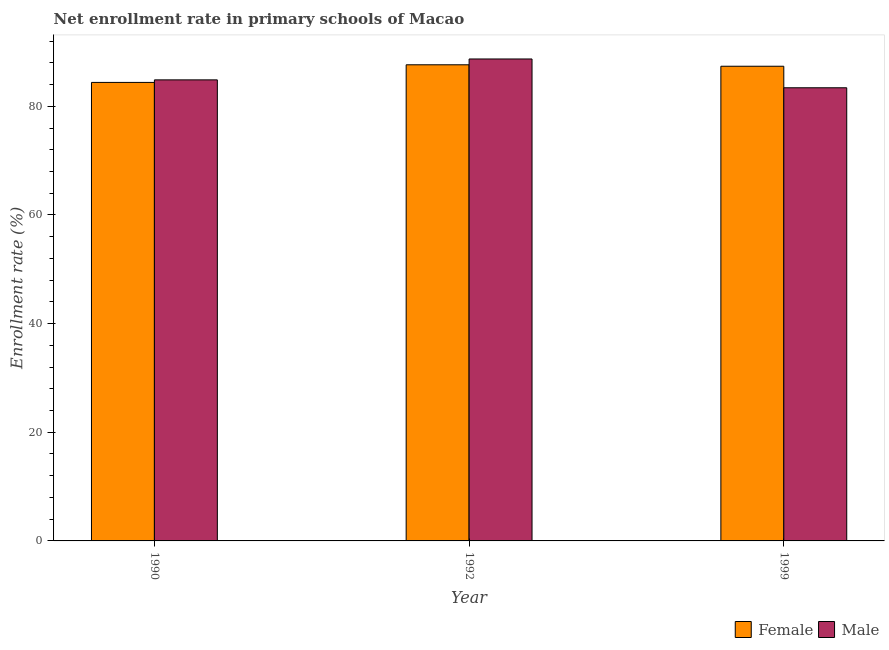How many different coloured bars are there?
Provide a succinct answer. 2. How many groups of bars are there?
Your response must be concise. 3. Are the number of bars per tick equal to the number of legend labels?
Offer a terse response. Yes. Are the number of bars on each tick of the X-axis equal?
Make the answer very short. Yes. How many bars are there on the 3rd tick from the left?
Provide a short and direct response. 2. What is the enrollment rate of male students in 1992?
Give a very brief answer. 88.71. Across all years, what is the maximum enrollment rate of female students?
Ensure brevity in your answer.  87.64. Across all years, what is the minimum enrollment rate of female students?
Give a very brief answer. 84.4. What is the total enrollment rate of male students in the graph?
Provide a short and direct response. 256.99. What is the difference between the enrollment rate of female students in 1990 and that in 1992?
Make the answer very short. -3.24. What is the difference between the enrollment rate of male students in 1992 and the enrollment rate of female students in 1999?
Provide a short and direct response. 5.3. What is the average enrollment rate of male students per year?
Your answer should be compact. 85.66. In how many years, is the enrollment rate of female students greater than 56 %?
Offer a very short reply. 3. What is the ratio of the enrollment rate of male students in 1990 to that in 1999?
Your response must be concise. 1.02. What is the difference between the highest and the second highest enrollment rate of female students?
Your answer should be compact. 0.27. What is the difference between the highest and the lowest enrollment rate of male students?
Your answer should be compact. 5.3. In how many years, is the enrollment rate of male students greater than the average enrollment rate of male students taken over all years?
Give a very brief answer. 1. Is the sum of the enrollment rate of female students in 1990 and 1999 greater than the maximum enrollment rate of male students across all years?
Your response must be concise. Yes. Are all the bars in the graph horizontal?
Make the answer very short. No. How many years are there in the graph?
Your answer should be very brief. 3. What is the difference between two consecutive major ticks on the Y-axis?
Give a very brief answer. 20. Are the values on the major ticks of Y-axis written in scientific E-notation?
Give a very brief answer. No. Does the graph contain any zero values?
Keep it short and to the point. No. Where does the legend appear in the graph?
Offer a very short reply. Bottom right. How are the legend labels stacked?
Keep it short and to the point. Horizontal. What is the title of the graph?
Ensure brevity in your answer.  Net enrollment rate in primary schools of Macao. What is the label or title of the X-axis?
Provide a short and direct response. Year. What is the label or title of the Y-axis?
Your answer should be very brief. Enrollment rate (%). What is the Enrollment rate (%) in Female in 1990?
Keep it short and to the point. 84.4. What is the Enrollment rate (%) in Male in 1990?
Your response must be concise. 84.87. What is the Enrollment rate (%) in Female in 1992?
Your response must be concise. 87.64. What is the Enrollment rate (%) of Male in 1992?
Provide a succinct answer. 88.71. What is the Enrollment rate (%) of Female in 1999?
Provide a succinct answer. 87.38. What is the Enrollment rate (%) of Male in 1999?
Make the answer very short. 83.41. Across all years, what is the maximum Enrollment rate (%) in Female?
Offer a terse response. 87.64. Across all years, what is the maximum Enrollment rate (%) of Male?
Provide a succinct answer. 88.71. Across all years, what is the minimum Enrollment rate (%) in Female?
Your answer should be compact. 84.4. Across all years, what is the minimum Enrollment rate (%) of Male?
Offer a very short reply. 83.41. What is the total Enrollment rate (%) in Female in the graph?
Provide a succinct answer. 259.42. What is the total Enrollment rate (%) in Male in the graph?
Provide a succinct answer. 256.99. What is the difference between the Enrollment rate (%) of Female in 1990 and that in 1992?
Keep it short and to the point. -3.24. What is the difference between the Enrollment rate (%) of Male in 1990 and that in 1992?
Make the answer very short. -3.85. What is the difference between the Enrollment rate (%) of Female in 1990 and that in 1999?
Your response must be concise. -2.98. What is the difference between the Enrollment rate (%) of Male in 1990 and that in 1999?
Provide a succinct answer. 1.46. What is the difference between the Enrollment rate (%) in Female in 1992 and that in 1999?
Your response must be concise. 0.27. What is the difference between the Enrollment rate (%) of Male in 1992 and that in 1999?
Your answer should be very brief. 5.3. What is the difference between the Enrollment rate (%) of Female in 1990 and the Enrollment rate (%) of Male in 1992?
Keep it short and to the point. -4.32. What is the difference between the Enrollment rate (%) in Female in 1990 and the Enrollment rate (%) in Male in 1999?
Your response must be concise. 0.99. What is the difference between the Enrollment rate (%) in Female in 1992 and the Enrollment rate (%) in Male in 1999?
Offer a very short reply. 4.23. What is the average Enrollment rate (%) in Female per year?
Your response must be concise. 86.47. What is the average Enrollment rate (%) of Male per year?
Offer a terse response. 85.66. In the year 1990, what is the difference between the Enrollment rate (%) of Female and Enrollment rate (%) of Male?
Ensure brevity in your answer.  -0.47. In the year 1992, what is the difference between the Enrollment rate (%) of Female and Enrollment rate (%) of Male?
Your response must be concise. -1.07. In the year 1999, what is the difference between the Enrollment rate (%) of Female and Enrollment rate (%) of Male?
Your answer should be very brief. 3.96. What is the ratio of the Enrollment rate (%) in Male in 1990 to that in 1992?
Give a very brief answer. 0.96. What is the ratio of the Enrollment rate (%) in Female in 1990 to that in 1999?
Your response must be concise. 0.97. What is the ratio of the Enrollment rate (%) in Male in 1990 to that in 1999?
Offer a terse response. 1.02. What is the ratio of the Enrollment rate (%) of Female in 1992 to that in 1999?
Your answer should be very brief. 1. What is the ratio of the Enrollment rate (%) of Male in 1992 to that in 1999?
Provide a short and direct response. 1.06. What is the difference between the highest and the second highest Enrollment rate (%) of Female?
Offer a very short reply. 0.27. What is the difference between the highest and the second highest Enrollment rate (%) of Male?
Offer a terse response. 3.85. What is the difference between the highest and the lowest Enrollment rate (%) of Female?
Make the answer very short. 3.24. What is the difference between the highest and the lowest Enrollment rate (%) of Male?
Offer a very short reply. 5.3. 